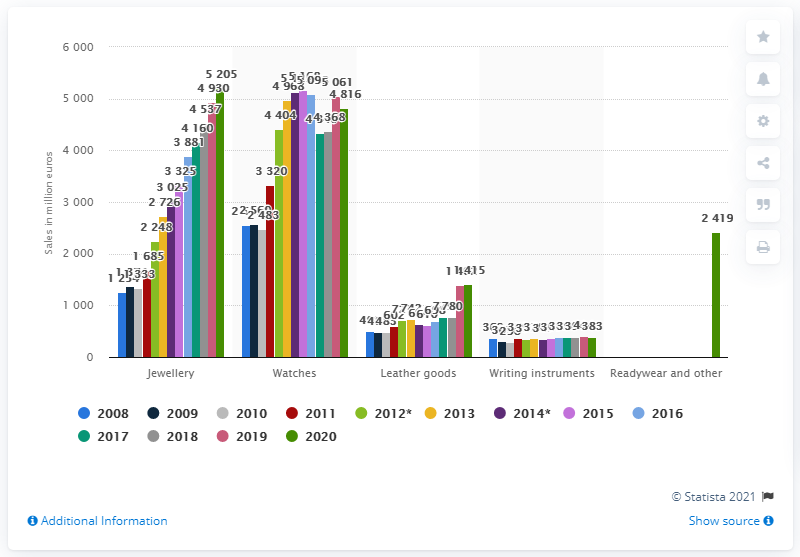Draw attention to some important aspects in this diagram. The Richemont Group's leather goods line had sales of 1415 in FY2020. 